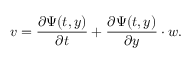<formula> <loc_0><loc_0><loc_500><loc_500>v = { \frac { \partial \Psi ( t , y ) } { \partial t } } + { \frac { \partial \Psi ( t , y ) } { \partial y } } \cdot w .</formula> 